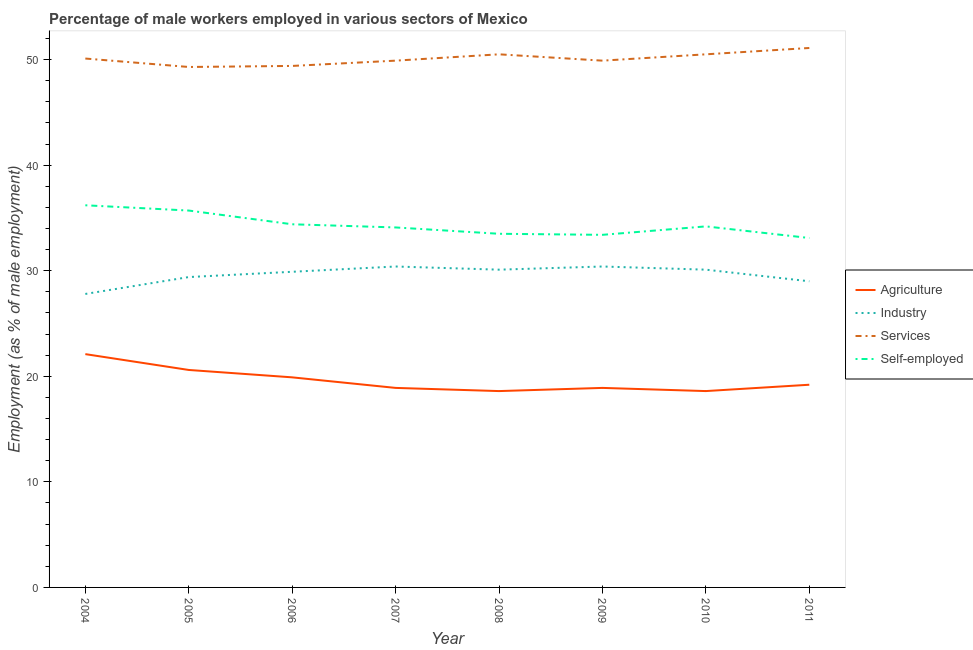Does the line corresponding to percentage of male workers in services intersect with the line corresponding to percentage of male workers in agriculture?
Provide a short and direct response. No. What is the percentage of male workers in services in 2010?
Offer a very short reply. 50.5. Across all years, what is the maximum percentage of male workers in agriculture?
Offer a very short reply. 22.1. Across all years, what is the minimum percentage of male workers in agriculture?
Your answer should be very brief. 18.6. In which year was the percentage of self employed male workers maximum?
Make the answer very short. 2004. What is the total percentage of male workers in agriculture in the graph?
Your answer should be very brief. 156.8. What is the difference between the percentage of self employed male workers in 2007 and that in 2009?
Make the answer very short. 0.7. What is the difference between the percentage of male workers in agriculture in 2011 and the percentage of self employed male workers in 2006?
Make the answer very short. -15.2. What is the average percentage of male workers in services per year?
Make the answer very short. 50.09. In the year 2008, what is the difference between the percentage of male workers in agriculture and percentage of self employed male workers?
Your answer should be very brief. -14.9. In how many years, is the percentage of self employed male workers greater than 2 %?
Offer a terse response. 8. What is the ratio of the percentage of male workers in services in 2008 to that in 2011?
Offer a terse response. 0.99. Is the percentage of male workers in industry in 2006 less than that in 2007?
Your answer should be compact. Yes. What is the difference between the highest and the second highest percentage of male workers in industry?
Offer a very short reply. 0. What is the difference between the highest and the lowest percentage of male workers in services?
Your answer should be very brief. 1.8. In how many years, is the percentage of male workers in agriculture greater than the average percentage of male workers in agriculture taken over all years?
Provide a succinct answer. 3. Is it the case that in every year, the sum of the percentage of male workers in agriculture and percentage of male workers in industry is greater than the sum of percentage of male workers in services and percentage of self employed male workers?
Make the answer very short. Yes. Does the percentage of male workers in industry monotonically increase over the years?
Give a very brief answer. No. How many years are there in the graph?
Make the answer very short. 8. What is the difference between two consecutive major ticks on the Y-axis?
Offer a very short reply. 10. How are the legend labels stacked?
Give a very brief answer. Vertical. What is the title of the graph?
Your answer should be compact. Percentage of male workers employed in various sectors of Mexico. Does "Subsidies and Transfers" appear as one of the legend labels in the graph?
Your answer should be compact. No. What is the label or title of the Y-axis?
Ensure brevity in your answer.  Employment (as % of male employment). What is the Employment (as % of male employment) in Agriculture in 2004?
Ensure brevity in your answer.  22.1. What is the Employment (as % of male employment) of Industry in 2004?
Provide a short and direct response. 27.8. What is the Employment (as % of male employment) in Services in 2004?
Make the answer very short. 50.1. What is the Employment (as % of male employment) in Self-employed in 2004?
Keep it short and to the point. 36.2. What is the Employment (as % of male employment) of Agriculture in 2005?
Give a very brief answer. 20.6. What is the Employment (as % of male employment) in Industry in 2005?
Ensure brevity in your answer.  29.4. What is the Employment (as % of male employment) in Services in 2005?
Give a very brief answer. 49.3. What is the Employment (as % of male employment) of Self-employed in 2005?
Your answer should be very brief. 35.7. What is the Employment (as % of male employment) in Agriculture in 2006?
Ensure brevity in your answer.  19.9. What is the Employment (as % of male employment) in Industry in 2006?
Offer a terse response. 29.9. What is the Employment (as % of male employment) of Services in 2006?
Your answer should be very brief. 49.4. What is the Employment (as % of male employment) of Self-employed in 2006?
Your answer should be very brief. 34.4. What is the Employment (as % of male employment) of Agriculture in 2007?
Provide a short and direct response. 18.9. What is the Employment (as % of male employment) of Industry in 2007?
Provide a short and direct response. 30.4. What is the Employment (as % of male employment) in Services in 2007?
Provide a short and direct response. 49.9. What is the Employment (as % of male employment) of Self-employed in 2007?
Your response must be concise. 34.1. What is the Employment (as % of male employment) in Agriculture in 2008?
Make the answer very short. 18.6. What is the Employment (as % of male employment) in Industry in 2008?
Ensure brevity in your answer.  30.1. What is the Employment (as % of male employment) of Services in 2008?
Your answer should be compact. 50.5. What is the Employment (as % of male employment) in Self-employed in 2008?
Ensure brevity in your answer.  33.5. What is the Employment (as % of male employment) in Agriculture in 2009?
Offer a very short reply. 18.9. What is the Employment (as % of male employment) of Industry in 2009?
Your answer should be compact. 30.4. What is the Employment (as % of male employment) of Services in 2009?
Offer a very short reply. 49.9. What is the Employment (as % of male employment) in Self-employed in 2009?
Your answer should be compact. 33.4. What is the Employment (as % of male employment) in Agriculture in 2010?
Keep it short and to the point. 18.6. What is the Employment (as % of male employment) in Industry in 2010?
Provide a succinct answer. 30.1. What is the Employment (as % of male employment) in Services in 2010?
Provide a short and direct response. 50.5. What is the Employment (as % of male employment) in Self-employed in 2010?
Provide a succinct answer. 34.2. What is the Employment (as % of male employment) of Agriculture in 2011?
Offer a very short reply. 19.2. What is the Employment (as % of male employment) of Services in 2011?
Give a very brief answer. 51.1. What is the Employment (as % of male employment) in Self-employed in 2011?
Your answer should be compact. 33.1. Across all years, what is the maximum Employment (as % of male employment) in Agriculture?
Offer a very short reply. 22.1. Across all years, what is the maximum Employment (as % of male employment) in Industry?
Give a very brief answer. 30.4. Across all years, what is the maximum Employment (as % of male employment) of Services?
Offer a terse response. 51.1. Across all years, what is the maximum Employment (as % of male employment) of Self-employed?
Provide a succinct answer. 36.2. Across all years, what is the minimum Employment (as % of male employment) in Agriculture?
Offer a very short reply. 18.6. Across all years, what is the minimum Employment (as % of male employment) of Industry?
Provide a short and direct response. 27.8. Across all years, what is the minimum Employment (as % of male employment) in Services?
Give a very brief answer. 49.3. Across all years, what is the minimum Employment (as % of male employment) in Self-employed?
Ensure brevity in your answer.  33.1. What is the total Employment (as % of male employment) in Agriculture in the graph?
Offer a very short reply. 156.8. What is the total Employment (as % of male employment) in Industry in the graph?
Keep it short and to the point. 237.1. What is the total Employment (as % of male employment) in Services in the graph?
Offer a terse response. 400.7. What is the total Employment (as % of male employment) in Self-employed in the graph?
Offer a very short reply. 274.6. What is the difference between the Employment (as % of male employment) in Services in 2004 and that in 2005?
Provide a short and direct response. 0.8. What is the difference between the Employment (as % of male employment) in Industry in 2004 and that in 2007?
Provide a succinct answer. -2.6. What is the difference between the Employment (as % of male employment) in Services in 2004 and that in 2007?
Make the answer very short. 0.2. What is the difference between the Employment (as % of male employment) in Self-employed in 2004 and that in 2007?
Your answer should be very brief. 2.1. What is the difference between the Employment (as % of male employment) in Agriculture in 2004 and that in 2008?
Make the answer very short. 3.5. What is the difference between the Employment (as % of male employment) of Self-employed in 2004 and that in 2008?
Provide a short and direct response. 2.7. What is the difference between the Employment (as % of male employment) of Industry in 2004 and that in 2009?
Provide a short and direct response. -2.6. What is the difference between the Employment (as % of male employment) in Industry in 2004 and that in 2010?
Provide a short and direct response. -2.3. What is the difference between the Employment (as % of male employment) of Self-employed in 2004 and that in 2010?
Give a very brief answer. 2. What is the difference between the Employment (as % of male employment) of Services in 2004 and that in 2011?
Give a very brief answer. -1. What is the difference between the Employment (as % of male employment) of Self-employed in 2004 and that in 2011?
Keep it short and to the point. 3.1. What is the difference between the Employment (as % of male employment) of Agriculture in 2005 and that in 2006?
Offer a terse response. 0.7. What is the difference between the Employment (as % of male employment) of Services in 2005 and that in 2006?
Your answer should be very brief. -0.1. What is the difference between the Employment (as % of male employment) of Self-employed in 2005 and that in 2007?
Provide a short and direct response. 1.6. What is the difference between the Employment (as % of male employment) of Industry in 2005 and that in 2008?
Your answer should be compact. -0.7. What is the difference between the Employment (as % of male employment) of Industry in 2005 and that in 2009?
Keep it short and to the point. -1. What is the difference between the Employment (as % of male employment) of Self-employed in 2005 and that in 2009?
Offer a very short reply. 2.3. What is the difference between the Employment (as % of male employment) of Services in 2005 and that in 2010?
Your answer should be very brief. -1.2. What is the difference between the Employment (as % of male employment) of Self-employed in 2005 and that in 2010?
Ensure brevity in your answer.  1.5. What is the difference between the Employment (as % of male employment) in Self-employed in 2005 and that in 2011?
Your response must be concise. 2.6. What is the difference between the Employment (as % of male employment) of Agriculture in 2006 and that in 2007?
Provide a short and direct response. 1. What is the difference between the Employment (as % of male employment) in Services in 2006 and that in 2007?
Provide a short and direct response. -0.5. What is the difference between the Employment (as % of male employment) of Self-employed in 2006 and that in 2007?
Keep it short and to the point. 0.3. What is the difference between the Employment (as % of male employment) in Agriculture in 2006 and that in 2008?
Provide a succinct answer. 1.3. What is the difference between the Employment (as % of male employment) of Industry in 2006 and that in 2008?
Ensure brevity in your answer.  -0.2. What is the difference between the Employment (as % of male employment) of Agriculture in 2006 and that in 2010?
Give a very brief answer. 1.3. What is the difference between the Employment (as % of male employment) of Industry in 2006 and that in 2010?
Give a very brief answer. -0.2. What is the difference between the Employment (as % of male employment) in Self-employed in 2006 and that in 2010?
Your answer should be compact. 0.2. What is the difference between the Employment (as % of male employment) of Agriculture in 2006 and that in 2011?
Your answer should be very brief. 0.7. What is the difference between the Employment (as % of male employment) in Industry in 2006 and that in 2011?
Keep it short and to the point. 0.9. What is the difference between the Employment (as % of male employment) in Agriculture in 2007 and that in 2008?
Keep it short and to the point. 0.3. What is the difference between the Employment (as % of male employment) of Industry in 2007 and that in 2008?
Offer a very short reply. 0.3. What is the difference between the Employment (as % of male employment) of Services in 2007 and that in 2008?
Provide a succinct answer. -0.6. What is the difference between the Employment (as % of male employment) in Agriculture in 2007 and that in 2009?
Ensure brevity in your answer.  0. What is the difference between the Employment (as % of male employment) of Services in 2007 and that in 2009?
Ensure brevity in your answer.  0. What is the difference between the Employment (as % of male employment) in Industry in 2007 and that in 2010?
Keep it short and to the point. 0.3. What is the difference between the Employment (as % of male employment) in Services in 2007 and that in 2010?
Give a very brief answer. -0.6. What is the difference between the Employment (as % of male employment) of Self-employed in 2007 and that in 2010?
Keep it short and to the point. -0.1. What is the difference between the Employment (as % of male employment) of Self-employed in 2008 and that in 2009?
Your answer should be very brief. 0.1. What is the difference between the Employment (as % of male employment) of Agriculture in 2008 and that in 2010?
Your answer should be compact. 0. What is the difference between the Employment (as % of male employment) in Industry in 2008 and that in 2010?
Offer a terse response. 0. What is the difference between the Employment (as % of male employment) in Services in 2008 and that in 2010?
Provide a short and direct response. 0. What is the difference between the Employment (as % of male employment) in Self-employed in 2008 and that in 2010?
Keep it short and to the point. -0.7. What is the difference between the Employment (as % of male employment) in Industry in 2008 and that in 2011?
Keep it short and to the point. 1.1. What is the difference between the Employment (as % of male employment) in Self-employed in 2008 and that in 2011?
Provide a succinct answer. 0.4. What is the difference between the Employment (as % of male employment) in Services in 2009 and that in 2010?
Make the answer very short. -0.6. What is the difference between the Employment (as % of male employment) of Self-employed in 2009 and that in 2010?
Your answer should be very brief. -0.8. What is the difference between the Employment (as % of male employment) in Agriculture in 2009 and that in 2011?
Your answer should be compact. -0.3. What is the difference between the Employment (as % of male employment) in Self-employed in 2009 and that in 2011?
Give a very brief answer. 0.3. What is the difference between the Employment (as % of male employment) in Self-employed in 2010 and that in 2011?
Make the answer very short. 1.1. What is the difference between the Employment (as % of male employment) of Agriculture in 2004 and the Employment (as % of male employment) of Services in 2005?
Offer a very short reply. -27.2. What is the difference between the Employment (as % of male employment) in Agriculture in 2004 and the Employment (as % of male employment) in Self-employed in 2005?
Ensure brevity in your answer.  -13.6. What is the difference between the Employment (as % of male employment) in Industry in 2004 and the Employment (as % of male employment) in Services in 2005?
Provide a succinct answer. -21.5. What is the difference between the Employment (as % of male employment) of Agriculture in 2004 and the Employment (as % of male employment) of Services in 2006?
Your response must be concise. -27.3. What is the difference between the Employment (as % of male employment) in Agriculture in 2004 and the Employment (as % of male employment) in Self-employed in 2006?
Your response must be concise. -12.3. What is the difference between the Employment (as % of male employment) of Industry in 2004 and the Employment (as % of male employment) of Services in 2006?
Your answer should be very brief. -21.6. What is the difference between the Employment (as % of male employment) of Industry in 2004 and the Employment (as % of male employment) of Self-employed in 2006?
Your answer should be compact. -6.6. What is the difference between the Employment (as % of male employment) of Services in 2004 and the Employment (as % of male employment) of Self-employed in 2006?
Make the answer very short. 15.7. What is the difference between the Employment (as % of male employment) of Agriculture in 2004 and the Employment (as % of male employment) of Industry in 2007?
Your answer should be compact. -8.3. What is the difference between the Employment (as % of male employment) in Agriculture in 2004 and the Employment (as % of male employment) in Services in 2007?
Your answer should be compact. -27.8. What is the difference between the Employment (as % of male employment) of Industry in 2004 and the Employment (as % of male employment) of Services in 2007?
Ensure brevity in your answer.  -22.1. What is the difference between the Employment (as % of male employment) in Agriculture in 2004 and the Employment (as % of male employment) in Services in 2008?
Provide a succinct answer. -28.4. What is the difference between the Employment (as % of male employment) in Agriculture in 2004 and the Employment (as % of male employment) in Self-employed in 2008?
Offer a very short reply. -11.4. What is the difference between the Employment (as % of male employment) of Industry in 2004 and the Employment (as % of male employment) of Services in 2008?
Your response must be concise. -22.7. What is the difference between the Employment (as % of male employment) in Services in 2004 and the Employment (as % of male employment) in Self-employed in 2008?
Provide a short and direct response. 16.6. What is the difference between the Employment (as % of male employment) in Agriculture in 2004 and the Employment (as % of male employment) in Services in 2009?
Offer a very short reply. -27.8. What is the difference between the Employment (as % of male employment) in Industry in 2004 and the Employment (as % of male employment) in Services in 2009?
Provide a succinct answer. -22.1. What is the difference between the Employment (as % of male employment) in Services in 2004 and the Employment (as % of male employment) in Self-employed in 2009?
Provide a short and direct response. 16.7. What is the difference between the Employment (as % of male employment) in Agriculture in 2004 and the Employment (as % of male employment) in Industry in 2010?
Your response must be concise. -8. What is the difference between the Employment (as % of male employment) in Agriculture in 2004 and the Employment (as % of male employment) in Services in 2010?
Offer a terse response. -28.4. What is the difference between the Employment (as % of male employment) in Agriculture in 2004 and the Employment (as % of male employment) in Self-employed in 2010?
Provide a succinct answer. -12.1. What is the difference between the Employment (as % of male employment) in Industry in 2004 and the Employment (as % of male employment) in Services in 2010?
Make the answer very short. -22.7. What is the difference between the Employment (as % of male employment) of Services in 2004 and the Employment (as % of male employment) of Self-employed in 2010?
Give a very brief answer. 15.9. What is the difference between the Employment (as % of male employment) of Agriculture in 2004 and the Employment (as % of male employment) of Self-employed in 2011?
Make the answer very short. -11. What is the difference between the Employment (as % of male employment) in Industry in 2004 and the Employment (as % of male employment) in Services in 2011?
Ensure brevity in your answer.  -23.3. What is the difference between the Employment (as % of male employment) of Services in 2004 and the Employment (as % of male employment) of Self-employed in 2011?
Your answer should be very brief. 17. What is the difference between the Employment (as % of male employment) in Agriculture in 2005 and the Employment (as % of male employment) in Services in 2006?
Offer a very short reply. -28.8. What is the difference between the Employment (as % of male employment) in Industry in 2005 and the Employment (as % of male employment) in Self-employed in 2006?
Ensure brevity in your answer.  -5. What is the difference between the Employment (as % of male employment) in Agriculture in 2005 and the Employment (as % of male employment) in Services in 2007?
Give a very brief answer. -29.3. What is the difference between the Employment (as % of male employment) in Industry in 2005 and the Employment (as % of male employment) in Services in 2007?
Make the answer very short. -20.5. What is the difference between the Employment (as % of male employment) in Industry in 2005 and the Employment (as % of male employment) in Self-employed in 2007?
Provide a short and direct response. -4.7. What is the difference between the Employment (as % of male employment) in Agriculture in 2005 and the Employment (as % of male employment) in Industry in 2008?
Your response must be concise. -9.5. What is the difference between the Employment (as % of male employment) of Agriculture in 2005 and the Employment (as % of male employment) of Services in 2008?
Provide a succinct answer. -29.9. What is the difference between the Employment (as % of male employment) of Agriculture in 2005 and the Employment (as % of male employment) of Self-employed in 2008?
Provide a short and direct response. -12.9. What is the difference between the Employment (as % of male employment) of Industry in 2005 and the Employment (as % of male employment) of Services in 2008?
Provide a succinct answer. -21.1. What is the difference between the Employment (as % of male employment) of Agriculture in 2005 and the Employment (as % of male employment) of Industry in 2009?
Make the answer very short. -9.8. What is the difference between the Employment (as % of male employment) of Agriculture in 2005 and the Employment (as % of male employment) of Services in 2009?
Give a very brief answer. -29.3. What is the difference between the Employment (as % of male employment) of Agriculture in 2005 and the Employment (as % of male employment) of Self-employed in 2009?
Offer a very short reply. -12.8. What is the difference between the Employment (as % of male employment) of Industry in 2005 and the Employment (as % of male employment) of Services in 2009?
Make the answer very short. -20.5. What is the difference between the Employment (as % of male employment) in Services in 2005 and the Employment (as % of male employment) in Self-employed in 2009?
Your answer should be compact. 15.9. What is the difference between the Employment (as % of male employment) in Agriculture in 2005 and the Employment (as % of male employment) in Industry in 2010?
Give a very brief answer. -9.5. What is the difference between the Employment (as % of male employment) in Agriculture in 2005 and the Employment (as % of male employment) in Services in 2010?
Provide a short and direct response. -29.9. What is the difference between the Employment (as % of male employment) of Industry in 2005 and the Employment (as % of male employment) of Services in 2010?
Offer a terse response. -21.1. What is the difference between the Employment (as % of male employment) of Agriculture in 2005 and the Employment (as % of male employment) of Industry in 2011?
Make the answer very short. -8.4. What is the difference between the Employment (as % of male employment) in Agriculture in 2005 and the Employment (as % of male employment) in Services in 2011?
Offer a terse response. -30.5. What is the difference between the Employment (as % of male employment) in Agriculture in 2005 and the Employment (as % of male employment) in Self-employed in 2011?
Provide a succinct answer. -12.5. What is the difference between the Employment (as % of male employment) of Industry in 2005 and the Employment (as % of male employment) of Services in 2011?
Your answer should be compact. -21.7. What is the difference between the Employment (as % of male employment) in Services in 2005 and the Employment (as % of male employment) in Self-employed in 2011?
Ensure brevity in your answer.  16.2. What is the difference between the Employment (as % of male employment) in Agriculture in 2006 and the Employment (as % of male employment) in Services in 2007?
Keep it short and to the point. -30. What is the difference between the Employment (as % of male employment) in Agriculture in 2006 and the Employment (as % of male employment) in Self-employed in 2007?
Keep it short and to the point. -14.2. What is the difference between the Employment (as % of male employment) of Industry in 2006 and the Employment (as % of male employment) of Self-employed in 2007?
Offer a terse response. -4.2. What is the difference between the Employment (as % of male employment) of Services in 2006 and the Employment (as % of male employment) of Self-employed in 2007?
Your answer should be compact. 15.3. What is the difference between the Employment (as % of male employment) of Agriculture in 2006 and the Employment (as % of male employment) of Services in 2008?
Your response must be concise. -30.6. What is the difference between the Employment (as % of male employment) of Agriculture in 2006 and the Employment (as % of male employment) of Self-employed in 2008?
Your response must be concise. -13.6. What is the difference between the Employment (as % of male employment) in Industry in 2006 and the Employment (as % of male employment) in Services in 2008?
Your response must be concise. -20.6. What is the difference between the Employment (as % of male employment) of Agriculture in 2006 and the Employment (as % of male employment) of Industry in 2009?
Give a very brief answer. -10.5. What is the difference between the Employment (as % of male employment) of Agriculture in 2006 and the Employment (as % of male employment) of Services in 2009?
Provide a short and direct response. -30. What is the difference between the Employment (as % of male employment) in Agriculture in 2006 and the Employment (as % of male employment) in Self-employed in 2009?
Keep it short and to the point. -13.5. What is the difference between the Employment (as % of male employment) of Industry in 2006 and the Employment (as % of male employment) of Services in 2009?
Ensure brevity in your answer.  -20. What is the difference between the Employment (as % of male employment) in Agriculture in 2006 and the Employment (as % of male employment) in Industry in 2010?
Your answer should be compact. -10.2. What is the difference between the Employment (as % of male employment) in Agriculture in 2006 and the Employment (as % of male employment) in Services in 2010?
Give a very brief answer. -30.6. What is the difference between the Employment (as % of male employment) of Agriculture in 2006 and the Employment (as % of male employment) of Self-employed in 2010?
Ensure brevity in your answer.  -14.3. What is the difference between the Employment (as % of male employment) of Industry in 2006 and the Employment (as % of male employment) of Services in 2010?
Keep it short and to the point. -20.6. What is the difference between the Employment (as % of male employment) of Services in 2006 and the Employment (as % of male employment) of Self-employed in 2010?
Keep it short and to the point. 15.2. What is the difference between the Employment (as % of male employment) in Agriculture in 2006 and the Employment (as % of male employment) in Services in 2011?
Offer a terse response. -31.2. What is the difference between the Employment (as % of male employment) in Agriculture in 2006 and the Employment (as % of male employment) in Self-employed in 2011?
Offer a terse response. -13.2. What is the difference between the Employment (as % of male employment) of Industry in 2006 and the Employment (as % of male employment) of Services in 2011?
Offer a terse response. -21.2. What is the difference between the Employment (as % of male employment) of Industry in 2006 and the Employment (as % of male employment) of Self-employed in 2011?
Offer a very short reply. -3.2. What is the difference between the Employment (as % of male employment) in Services in 2006 and the Employment (as % of male employment) in Self-employed in 2011?
Your answer should be very brief. 16.3. What is the difference between the Employment (as % of male employment) of Agriculture in 2007 and the Employment (as % of male employment) of Services in 2008?
Make the answer very short. -31.6. What is the difference between the Employment (as % of male employment) of Agriculture in 2007 and the Employment (as % of male employment) of Self-employed in 2008?
Give a very brief answer. -14.6. What is the difference between the Employment (as % of male employment) of Industry in 2007 and the Employment (as % of male employment) of Services in 2008?
Offer a very short reply. -20.1. What is the difference between the Employment (as % of male employment) in Agriculture in 2007 and the Employment (as % of male employment) in Industry in 2009?
Make the answer very short. -11.5. What is the difference between the Employment (as % of male employment) of Agriculture in 2007 and the Employment (as % of male employment) of Services in 2009?
Keep it short and to the point. -31. What is the difference between the Employment (as % of male employment) of Agriculture in 2007 and the Employment (as % of male employment) of Self-employed in 2009?
Give a very brief answer. -14.5. What is the difference between the Employment (as % of male employment) of Industry in 2007 and the Employment (as % of male employment) of Services in 2009?
Ensure brevity in your answer.  -19.5. What is the difference between the Employment (as % of male employment) in Industry in 2007 and the Employment (as % of male employment) in Self-employed in 2009?
Ensure brevity in your answer.  -3. What is the difference between the Employment (as % of male employment) of Agriculture in 2007 and the Employment (as % of male employment) of Services in 2010?
Make the answer very short. -31.6. What is the difference between the Employment (as % of male employment) in Agriculture in 2007 and the Employment (as % of male employment) in Self-employed in 2010?
Your answer should be very brief. -15.3. What is the difference between the Employment (as % of male employment) in Industry in 2007 and the Employment (as % of male employment) in Services in 2010?
Provide a succinct answer. -20.1. What is the difference between the Employment (as % of male employment) of Industry in 2007 and the Employment (as % of male employment) of Self-employed in 2010?
Offer a very short reply. -3.8. What is the difference between the Employment (as % of male employment) of Agriculture in 2007 and the Employment (as % of male employment) of Industry in 2011?
Ensure brevity in your answer.  -10.1. What is the difference between the Employment (as % of male employment) of Agriculture in 2007 and the Employment (as % of male employment) of Services in 2011?
Your response must be concise. -32.2. What is the difference between the Employment (as % of male employment) of Industry in 2007 and the Employment (as % of male employment) of Services in 2011?
Offer a very short reply. -20.7. What is the difference between the Employment (as % of male employment) of Industry in 2007 and the Employment (as % of male employment) of Self-employed in 2011?
Make the answer very short. -2.7. What is the difference between the Employment (as % of male employment) in Services in 2007 and the Employment (as % of male employment) in Self-employed in 2011?
Give a very brief answer. 16.8. What is the difference between the Employment (as % of male employment) of Agriculture in 2008 and the Employment (as % of male employment) of Services in 2009?
Provide a succinct answer. -31.3. What is the difference between the Employment (as % of male employment) in Agriculture in 2008 and the Employment (as % of male employment) in Self-employed in 2009?
Keep it short and to the point. -14.8. What is the difference between the Employment (as % of male employment) of Industry in 2008 and the Employment (as % of male employment) of Services in 2009?
Provide a succinct answer. -19.8. What is the difference between the Employment (as % of male employment) in Industry in 2008 and the Employment (as % of male employment) in Self-employed in 2009?
Give a very brief answer. -3.3. What is the difference between the Employment (as % of male employment) of Agriculture in 2008 and the Employment (as % of male employment) of Services in 2010?
Your answer should be compact. -31.9. What is the difference between the Employment (as % of male employment) of Agriculture in 2008 and the Employment (as % of male employment) of Self-employed in 2010?
Give a very brief answer. -15.6. What is the difference between the Employment (as % of male employment) of Industry in 2008 and the Employment (as % of male employment) of Services in 2010?
Your response must be concise. -20.4. What is the difference between the Employment (as % of male employment) in Agriculture in 2008 and the Employment (as % of male employment) in Services in 2011?
Your answer should be very brief. -32.5. What is the difference between the Employment (as % of male employment) in Industry in 2008 and the Employment (as % of male employment) in Self-employed in 2011?
Give a very brief answer. -3. What is the difference between the Employment (as % of male employment) of Services in 2008 and the Employment (as % of male employment) of Self-employed in 2011?
Offer a very short reply. 17.4. What is the difference between the Employment (as % of male employment) of Agriculture in 2009 and the Employment (as % of male employment) of Services in 2010?
Provide a short and direct response. -31.6. What is the difference between the Employment (as % of male employment) of Agriculture in 2009 and the Employment (as % of male employment) of Self-employed in 2010?
Your answer should be very brief. -15.3. What is the difference between the Employment (as % of male employment) of Industry in 2009 and the Employment (as % of male employment) of Services in 2010?
Make the answer very short. -20.1. What is the difference between the Employment (as % of male employment) in Industry in 2009 and the Employment (as % of male employment) in Self-employed in 2010?
Provide a succinct answer. -3.8. What is the difference between the Employment (as % of male employment) in Services in 2009 and the Employment (as % of male employment) in Self-employed in 2010?
Your answer should be very brief. 15.7. What is the difference between the Employment (as % of male employment) in Agriculture in 2009 and the Employment (as % of male employment) in Services in 2011?
Give a very brief answer. -32.2. What is the difference between the Employment (as % of male employment) of Agriculture in 2009 and the Employment (as % of male employment) of Self-employed in 2011?
Your response must be concise. -14.2. What is the difference between the Employment (as % of male employment) of Industry in 2009 and the Employment (as % of male employment) of Services in 2011?
Offer a very short reply. -20.7. What is the difference between the Employment (as % of male employment) of Industry in 2009 and the Employment (as % of male employment) of Self-employed in 2011?
Ensure brevity in your answer.  -2.7. What is the difference between the Employment (as % of male employment) of Agriculture in 2010 and the Employment (as % of male employment) of Industry in 2011?
Provide a succinct answer. -10.4. What is the difference between the Employment (as % of male employment) of Agriculture in 2010 and the Employment (as % of male employment) of Services in 2011?
Your answer should be very brief. -32.5. What is the difference between the Employment (as % of male employment) of Agriculture in 2010 and the Employment (as % of male employment) of Self-employed in 2011?
Keep it short and to the point. -14.5. What is the difference between the Employment (as % of male employment) in Industry in 2010 and the Employment (as % of male employment) in Services in 2011?
Give a very brief answer. -21. What is the difference between the Employment (as % of male employment) in Services in 2010 and the Employment (as % of male employment) in Self-employed in 2011?
Your answer should be compact. 17.4. What is the average Employment (as % of male employment) of Agriculture per year?
Your answer should be very brief. 19.6. What is the average Employment (as % of male employment) in Industry per year?
Make the answer very short. 29.64. What is the average Employment (as % of male employment) in Services per year?
Offer a very short reply. 50.09. What is the average Employment (as % of male employment) in Self-employed per year?
Provide a short and direct response. 34.33. In the year 2004, what is the difference between the Employment (as % of male employment) of Agriculture and Employment (as % of male employment) of Industry?
Provide a succinct answer. -5.7. In the year 2004, what is the difference between the Employment (as % of male employment) of Agriculture and Employment (as % of male employment) of Services?
Ensure brevity in your answer.  -28. In the year 2004, what is the difference between the Employment (as % of male employment) in Agriculture and Employment (as % of male employment) in Self-employed?
Provide a succinct answer. -14.1. In the year 2004, what is the difference between the Employment (as % of male employment) in Industry and Employment (as % of male employment) in Services?
Keep it short and to the point. -22.3. In the year 2005, what is the difference between the Employment (as % of male employment) of Agriculture and Employment (as % of male employment) of Industry?
Your answer should be compact. -8.8. In the year 2005, what is the difference between the Employment (as % of male employment) of Agriculture and Employment (as % of male employment) of Services?
Your answer should be very brief. -28.7. In the year 2005, what is the difference between the Employment (as % of male employment) of Agriculture and Employment (as % of male employment) of Self-employed?
Make the answer very short. -15.1. In the year 2005, what is the difference between the Employment (as % of male employment) in Industry and Employment (as % of male employment) in Services?
Offer a terse response. -19.9. In the year 2006, what is the difference between the Employment (as % of male employment) in Agriculture and Employment (as % of male employment) in Industry?
Provide a succinct answer. -10. In the year 2006, what is the difference between the Employment (as % of male employment) of Agriculture and Employment (as % of male employment) of Services?
Provide a succinct answer. -29.5. In the year 2006, what is the difference between the Employment (as % of male employment) of Agriculture and Employment (as % of male employment) of Self-employed?
Your answer should be compact. -14.5. In the year 2006, what is the difference between the Employment (as % of male employment) in Industry and Employment (as % of male employment) in Services?
Your answer should be compact. -19.5. In the year 2006, what is the difference between the Employment (as % of male employment) in Services and Employment (as % of male employment) in Self-employed?
Your response must be concise. 15. In the year 2007, what is the difference between the Employment (as % of male employment) in Agriculture and Employment (as % of male employment) in Services?
Your response must be concise. -31. In the year 2007, what is the difference between the Employment (as % of male employment) of Agriculture and Employment (as % of male employment) of Self-employed?
Keep it short and to the point. -15.2. In the year 2007, what is the difference between the Employment (as % of male employment) in Industry and Employment (as % of male employment) in Services?
Keep it short and to the point. -19.5. In the year 2007, what is the difference between the Employment (as % of male employment) of Industry and Employment (as % of male employment) of Self-employed?
Your response must be concise. -3.7. In the year 2007, what is the difference between the Employment (as % of male employment) of Services and Employment (as % of male employment) of Self-employed?
Ensure brevity in your answer.  15.8. In the year 2008, what is the difference between the Employment (as % of male employment) in Agriculture and Employment (as % of male employment) in Services?
Your answer should be very brief. -31.9. In the year 2008, what is the difference between the Employment (as % of male employment) of Agriculture and Employment (as % of male employment) of Self-employed?
Keep it short and to the point. -14.9. In the year 2008, what is the difference between the Employment (as % of male employment) in Industry and Employment (as % of male employment) in Services?
Give a very brief answer. -20.4. In the year 2008, what is the difference between the Employment (as % of male employment) in Industry and Employment (as % of male employment) in Self-employed?
Ensure brevity in your answer.  -3.4. In the year 2008, what is the difference between the Employment (as % of male employment) in Services and Employment (as % of male employment) in Self-employed?
Your answer should be very brief. 17. In the year 2009, what is the difference between the Employment (as % of male employment) of Agriculture and Employment (as % of male employment) of Services?
Your answer should be compact. -31. In the year 2009, what is the difference between the Employment (as % of male employment) of Industry and Employment (as % of male employment) of Services?
Your response must be concise. -19.5. In the year 2009, what is the difference between the Employment (as % of male employment) in Services and Employment (as % of male employment) in Self-employed?
Offer a very short reply. 16.5. In the year 2010, what is the difference between the Employment (as % of male employment) of Agriculture and Employment (as % of male employment) of Industry?
Offer a terse response. -11.5. In the year 2010, what is the difference between the Employment (as % of male employment) in Agriculture and Employment (as % of male employment) in Services?
Make the answer very short. -31.9. In the year 2010, what is the difference between the Employment (as % of male employment) of Agriculture and Employment (as % of male employment) of Self-employed?
Your answer should be very brief. -15.6. In the year 2010, what is the difference between the Employment (as % of male employment) of Industry and Employment (as % of male employment) of Services?
Keep it short and to the point. -20.4. In the year 2010, what is the difference between the Employment (as % of male employment) of Industry and Employment (as % of male employment) of Self-employed?
Give a very brief answer. -4.1. In the year 2010, what is the difference between the Employment (as % of male employment) in Services and Employment (as % of male employment) in Self-employed?
Offer a terse response. 16.3. In the year 2011, what is the difference between the Employment (as % of male employment) in Agriculture and Employment (as % of male employment) in Services?
Make the answer very short. -31.9. In the year 2011, what is the difference between the Employment (as % of male employment) in Industry and Employment (as % of male employment) in Services?
Offer a terse response. -22.1. In the year 2011, what is the difference between the Employment (as % of male employment) of Industry and Employment (as % of male employment) of Self-employed?
Keep it short and to the point. -4.1. In the year 2011, what is the difference between the Employment (as % of male employment) of Services and Employment (as % of male employment) of Self-employed?
Keep it short and to the point. 18. What is the ratio of the Employment (as % of male employment) of Agriculture in 2004 to that in 2005?
Give a very brief answer. 1.07. What is the ratio of the Employment (as % of male employment) in Industry in 2004 to that in 2005?
Your answer should be compact. 0.95. What is the ratio of the Employment (as % of male employment) of Services in 2004 to that in 2005?
Give a very brief answer. 1.02. What is the ratio of the Employment (as % of male employment) of Agriculture in 2004 to that in 2006?
Offer a terse response. 1.11. What is the ratio of the Employment (as % of male employment) in Industry in 2004 to that in 2006?
Make the answer very short. 0.93. What is the ratio of the Employment (as % of male employment) of Services in 2004 to that in 2006?
Provide a short and direct response. 1.01. What is the ratio of the Employment (as % of male employment) in Self-employed in 2004 to that in 2006?
Offer a terse response. 1.05. What is the ratio of the Employment (as % of male employment) in Agriculture in 2004 to that in 2007?
Your answer should be very brief. 1.17. What is the ratio of the Employment (as % of male employment) of Industry in 2004 to that in 2007?
Your response must be concise. 0.91. What is the ratio of the Employment (as % of male employment) in Services in 2004 to that in 2007?
Your answer should be very brief. 1. What is the ratio of the Employment (as % of male employment) of Self-employed in 2004 to that in 2007?
Offer a terse response. 1.06. What is the ratio of the Employment (as % of male employment) in Agriculture in 2004 to that in 2008?
Make the answer very short. 1.19. What is the ratio of the Employment (as % of male employment) of Industry in 2004 to that in 2008?
Ensure brevity in your answer.  0.92. What is the ratio of the Employment (as % of male employment) of Services in 2004 to that in 2008?
Provide a succinct answer. 0.99. What is the ratio of the Employment (as % of male employment) of Self-employed in 2004 to that in 2008?
Provide a short and direct response. 1.08. What is the ratio of the Employment (as % of male employment) of Agriculture in 2004 to that in 2009?
Your answer should be compact. 1.17. What is the ratio of the Employment (as % of male employment) of Industry in 2004 to that in 2009?
Keep it short and to the point. 0.91. What is the ratio of the Employment (as % of male employment) in Self-employed in 2004 to that in 2009?
Make the answer very short. 1.08. What is the ratio of the Employment (as % of male employment) in Agriculture in 2004 to that in 2010?
Offer a terse response. 1.19. What is the ratio of the Employment (as % of male employment) of Industry in 2004 to that in 2010?
Give a very brief answer. 0.92. What is the ratio of the Employment (as % of male employment) in Self-employed in 2004 to that in 2010?
Ensure brevity in your answer.  1.06. What is the ratio of the Employment (as % of male employment) of Agriculture in 2004 to that in 2011?
Your response must be concise. 1.15. What is the ratio of the Employment (as % of male employment) in Industry in 2004 to that in 2011?
Ensure brevity in your answer.  0.96. What is the ratio of the Employment (as % of male employment) in Services in 2004 to that in 2011?
Your response must be concise. 0.98. What is the ratio of the Employment (as % of male employment) in Self-employed in 2004 to that in 2011?
Provide a short and direct response. 1.09. What is the ratio of the Employment (as % of male employment) of Agriculture in 2005 to that in 2006?
Make the answer very short. 1.04. What is the ratio of the Employment (as % of male employment) of Industry in 2005 to that in 2006?
Offer a very short reply. 0.98. What is the ratio of the Employment (as % of male employment) in Services in 2005 to that in 2006?
Ensure brevity in your answer.  1. What is the ratio of the Employment (as % of male employment) in Self-employed in 2005 to that in 2006?
Your answer should be compact. 1.04. What is the ratio of the Employment (as % of male employment) in Agriculture in 2005 to that in 2007?
Make the answer very short. 1.09. What is the ratio of the Employment (as % of male employment) of Industry in 2005 to that in 2007?
Your response must be concise. 0.97. What is the ratio of the Employment (as % of male employment) of Self-employed in 2005 to that in 2007?
Provide a short and direct response. 1.05. What is the ratio of the Employment (as % of male employment) in Agriculture in 2005 to that in 2008?
Offer a terse response. 1.11. What is the ratio of the Employment (as % of male employment) in Industry in 2005 to that in 2008?
Offer a terse response. 0.98. What is the ratio of the Employment (as % of male employment) of Services in 2005 to that in 2008?
Your answer should be very brief. 0.98. What is the ratio of the Employment (as % of male employment) of Self-employed in 2005 to that in 2008?
Make the answer very short. 1.07. What is the ratio of the Employment (as % of male employment) in Agriculture in 2005 to that in 2009?
Provide a short and direct response. 1.09. What is the ratio of the Employment (as % of male employment) in Industry in 2005 to that in 2009?
Offer a very short reply. 0.97. What is the ratio of the Employment (as % of male employment) of Self-employed in 2005 to that in 2009?
Offer a very short reply. 1.07. What is the ratio of the Employment (as % of male employment) of Agriculture in 2005 to that in 2010?
Offer a very short reply. 1.11. What is the ratio of the Employment (as % of male employment) in Industry in 2005 to that in 2010?
Offer a very short reply. 0.98. What is the ratio of the Employment (as % of male employment) in Services in 2005 to that in 2010?
Keep it short and to the point. 0.98. What is the ratio of the Employment (as % of male employment) of Self-employed in 2005 to that in 2010?
Provide a succinct answer. 1.04. What is the ratio of the Employment (as % of male employment) in Agriculture in 2005 to that in 2011?
Your answer should be compact. 1.07. What is the ratio of the Employment (as % of male employment) of Industry in 2005 to that in 2011?
Make the answer very short. 1.01. What is the ratio of the Employment (as % of male employment) of Services in 2005 to that in 2011?
Offer a terse response. 0.96. What is the ratio of the Employment (as % of male employment) in Self-employed in 2005 to that in 2011?
Keep it short and to the point. 1.08. What is the ratio of the Employment (as % of male employment) in Agriculture in 2006 to that in 2007?
Offer a terse response. 1.05. What is the ratio of the Employment (as % of male employment) of Industry in 2006 to that in 2007?
Offer a very short reply. 0.98. What is the ratio of the Employment (as % of male employment) of Self-employed in 2006 to that in 2007?
Make the answer very short. 1.01. What is the ratio of the Employment (as % of male employment) in Agriculture in 2006 to that in 2008?
Keep it short and to the point. 1.07. What is the ratio of the Employment (as % of male employment) of Industry in 2006 to that in 2008?
Give a very brief answer. 0.99. What is the ratio of the Employment (as % of male employment) of Services in 2006 to that in 2008?
Ensure brevity in your answer.  0.98. What is the ratio of the Employment (as % of male employment) in Self-employed in 2006 to that in 2008?
Provide a short and direct response. 1.03. What is the ratio of the Employment (as % of male employment) in Agriculture in 2006 to that in 2009?
Offer a very short reply. 1.05. What is the ratio of the Employment (as % of male employment) of Industry in 2006 to that in 2009?
Your answer should be very brief. 0.98. What is the ratio of the Employment (as % of male employment) of Services in 2006 to that in 2009?
Your answer should be compact. 0.99. What is the ratio of the Employment (as % of male employment) of Self-employed in 2006 to that in 2009?
Offer a very short reply. 1.03. What is the ratio of the Employment (as % of male employment) of Agriculture in 2006 to that in 2010?
Your answer should be compact. 1.07. What is the ratio of the Employment (as % of male employment) in Industry in 2006 to that in 2010?
Ensure brevity in your answer.  0.99. What is the ratio of the Employment (as % of male employment) of Services in 2006 to that in 2010?
Make the answer very short. 0.98. What is the ratio of the Employment (as % of male employment) of Self-employed in 2006 to that in 2010?
Ensure brevity in your answer.  1.01. What is the ratio of the Employment (as % of male employment) of Agriculture in 2006 to that in 2011?
Provide a short and direct response. 1.04. What is the ratio of the Employment (as % of male employment) of Industry in 2006 to that in 2011?
Keep it short and to the point. 1.03. What is the ratio of the Employment (as % of male employment) of Services in 2006 to that in 2011?
Give a very brief answer. 0.97. What is the ratio of the Employment (as % of male employment) in Self-employed in 2006 to that in 2011?
Make the answer very short. 1.04. What is the ratio of the Employment (as % of male employment) in Agriculture in 2007 to that in 2008?
Your answer should be compact. 1.02. What is the ratio of the Employment (as % of male employment) of Self-employed in 2007 to that in 2008?
Keep it short and to the point. 1.02. What is the ratio of the Employment (as % of male employment) in Industry in 2007 to that in 2009?
Make the answer very short. 1. What is the ratio of the Employment (as % of male employment) in Self-employed in 2007 to that in 2009?
Ensure brevity in your answer.  1.02. What is the ratio of the Employment (as % of male employment) in Agriculture in 2007 to that in 2010?
Your answer should be very brief. 1.02. What is the ratio of the Employment (as % of male employment) of Industry in 2007 to that in 2010?
Keep it short and to the point. 1.01. What is the ratio of the Employment (as % of male employment) of Self-employed in 2007 to that in 2010?
Ensure brevity in your answer.  1. What is the ratio of the Employment (as % of male employment) in Agriculture in 2007 to that in 2011?
Make the answer very short. 0.98. What is the ratio of the Employment (as % of male employment) of Industry in 2007 to that in 2011?
Your answer should be compact. 1.05. What is the ratio of the Employment (as % of male employment) of Services in 2007 to that in 2011?
Give a very brief answer. 0.98. What is the ratio of the Employment (as % of male employment) of Self-employed in 2007 to that in 2011?
Offer a very short reply. 1.03. What is the ratio of the Employment (as % of male employment) of Agriculture in 2008 to that in 2009?
Ensure brevity in your answer.  0.98. What is the ratio of the Employment (as % of male employment) in Industry in 2008 to that in 2009?
Ensure brevity in your answer.  0.99. What is the ratio of the Employment (as % of male employment) of Agriculture in 2008 to that in 2010?
Offer a terse response. 1. What is the ratio of the Employment (as % of male employment) of Services in 2008 to that in 2010?
Your answer should be compact. 1. What is the ratio of the Employment (as % of male employment) in Self-employed in 2008 to that in 2010?
Ensure brevity in your answer.  0.98. What is the ratio of the Employment (as % of male employment) in Agriculture in 2008 to that in 2011?
Offer a very short reply. 0.97. What is the ratio of the Employment (as % of male employment) of Industry in 2008 to that in 2011?
Ensure brevity in your answer.  1.04. What is the ratio of the Employment (as % of male employment) of Services in 2008 to that in 2011?
Your response must be concise. 0.99. What is the ratio of the Employment (as % of male employment) of Self-employed in 2008 to that in 2011?
Your response must be concise. 1.01. What is the ratio of the Employment (as % of male employment) in Agriculture in 2009 to that in 2010?
Offer a very short reply. 1.02. What is the ratio of the Employment (as % of male employment) in Industry in 2009 to that in 2010?
Offer a terse response. 1.01. What is the ratio of the Employment (as % of male employment) in Self-employed in 2009 to that in 2010?
Your response must be concise. 0.98. What is the ratio of the Employment (as % of male employment) in Agriculture in 2009 to that in 2011?
Give a very brief answer. 0.98. What is the ratio of the Employment (as % of male employment) in Industry in 2009 to that in 2011?
Give a very brief answer. 1.05. What is the ratio of the Employment (as % of male employment) of Services in 2009 to that in 2011?
Offer a very short reply. 0.98. What is the ratio of the Employment (as % of male employment) in Self-employed in 2009 to that in 2011?
Keep it short and to the point. 1.01. What is the ratio of the Employment (as % of male employment) of Agriculture in 2010 to that in 2011?
Ensure brevity in your answer.  0.97. What is the ratio of the Employment (as % of male employment) of Industry in 2010 to that in 2011?
Offer a terse response. 1.04. What is the ratio of the Employment (as % of male employment) of Services in 2010 to that in 2011?
Provide a succinct answer. 0.99. What is the ratio of the Employment (as % of male employment) of Self-employed in 2010 to that in 2011?
Your response must be concise. 1.03. What is the difference between the highest and the second highest Employment (as % of male employment) of Agriculture?
Your response must be concise. 1.5. What is the difference between the highest and the second highest Employment (as % of male employment) of Services?
Keep it short and to the point. 0.6. What is the difference between the highest and the lowest Employment (as % of male employment) in Industry?
Give a very brief answer. 2.6. What is the difference between the highest and the lowest Employment (as % of male employment) in Self-employed?
Ensure brevity in your answer.  3.1. 